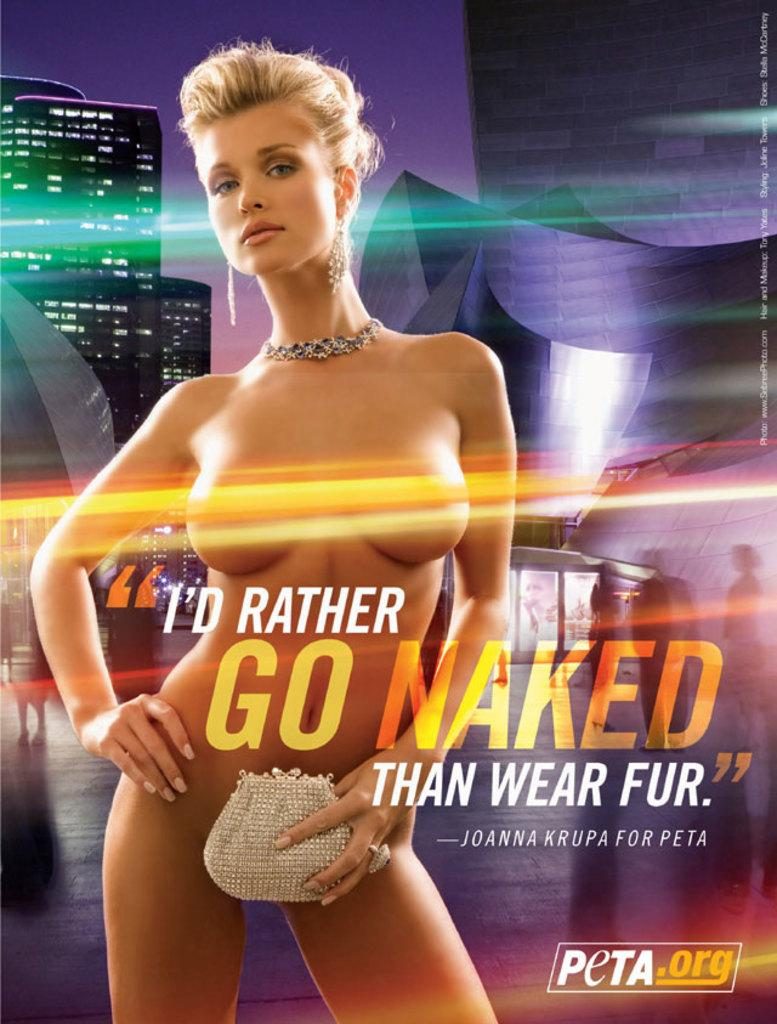<image>
Relay a brief, clear account of the picture shown. A bill board that says I'd Rather Go Naked than Wear Fur. 